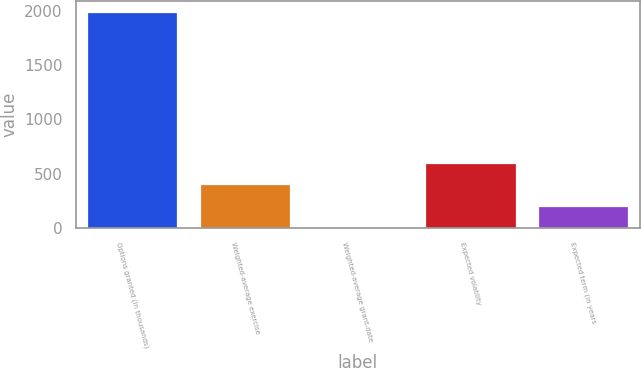<chart> <loc_0><loc_0><loc_500><loc_500><bar_chart><fcel>Options granted (in thousands)<fcel>Weighted-average exercise<fcel>Weighted-average grant-date<fcel>Expected volatility<fcel>Expected term (in years<nl><fcel>1992<fcel>400.68<fcel>2.84<fcel>599.6<fcel>201.76<nl></chart> 